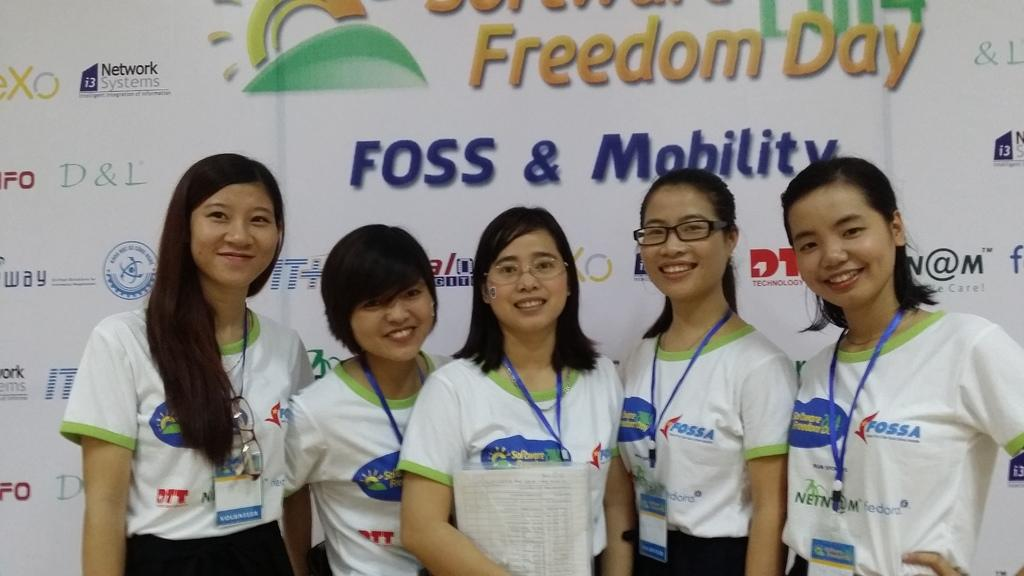Who is present at the bottom of the image? There are women at the bottom of the image. What are the women wearing? The women are wearing badges. What is the facial expression of the women? The women are smiling. What position are the women in? The women are standing. What is one of the women holding? One of the women is holding a document. What can be seen in the background of the image? There is a banner in the background of the image. What type of hair is visible on the vest of the woman in the image? There is no mention of a vest or hair on a vest in the image; the women are wearing badges and holding a document. 